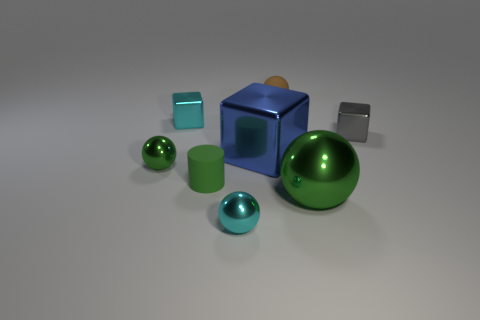Is there any other thing that is the same shape as the tiny green matte thing?
Provide a succinct answer. No. Does the cylinder have the same color as the large ball?
Provide a succinct answer. Yes. What number of big shiny things are behind the cyan thing to the right of the rubber thing in front of the brown object?
Provide a succinct answer. 2. Is there a large object of the same color as the tiny cylinder?
Keep it short and to the point. Yes. There is another object that is the same size as the blue metallic thing; what is its color?
Ensure brevity in your answer.  Green. What is the shape of the small rubber object to the right of the sphere that is in front of the green metal ball right of the tiny cyan metal cube?
Your response must be concise. Sphere. There is a metallic ball that is on the right side of the blue metallic thing; what number of large objects are behind it?
Keep it short and to the point. 1. There is a big object to the right of the blue block; does it have the same shape as the green metal object that is left of the cyan ball?
Your answer should be very brief. Yes. There is a tiny cyan sphere; how many tiny cyan objects are behind it?
Give a very brief answer. 1. Do the tiny cyan object left of the tiny cyan metal ball and the large block have the same material?
Your answer should be compact. Yes. 